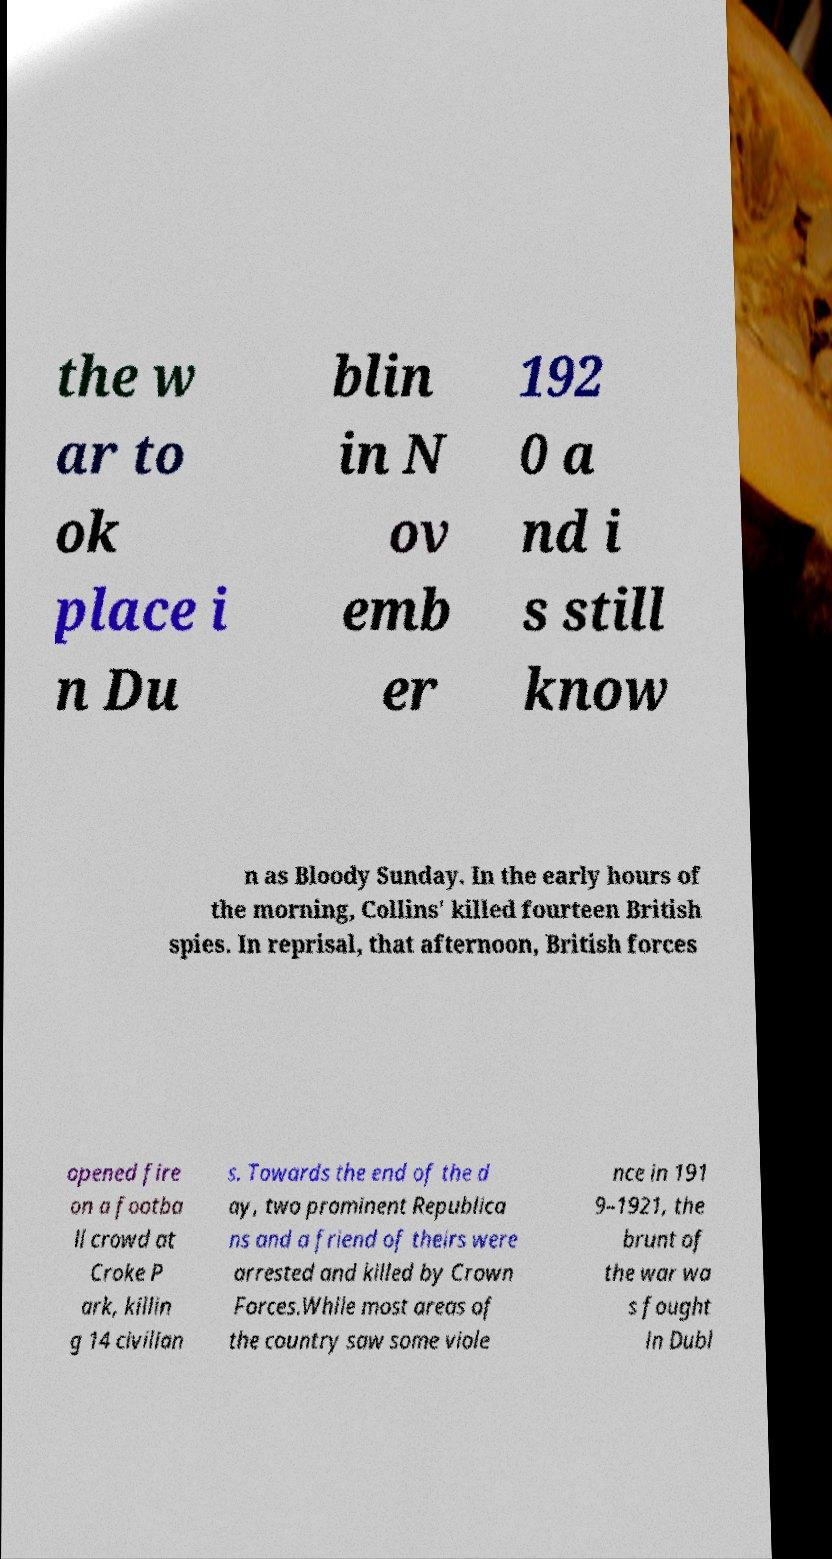I need the written content from this picture converted into text. Can you do that? the w ar to ok place i n Du blin in N ov emb er 192 0 a nd i s still know n as Bloody Sunday. In the early hours of the morning, Collins' killed fourteen British spies. In reprisal, that afternoon, British forces opened fire on a footba ll crowd at Croke P ark, killin g 14 civilian s. Towards the end of the d ay, two prominent Republica ns and a friend of theirs were arrested and killed by Crown Forces.While most areas of the country saw some viole nce in 191 9–1921, the brunt of the war wa s fought in Dubl 